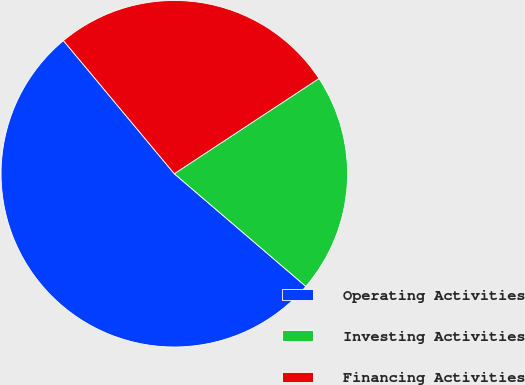Convert chart to OTSL. <chart><loc_0><loc_0><loc_500><loc_500><pie_chart><fcel>Operating Activities<fcel>Investing Activities<fcel>Financing Activities<nl><fcel>52.68%<fcel>20.54%<fcel>26.79%<nl></chart> 